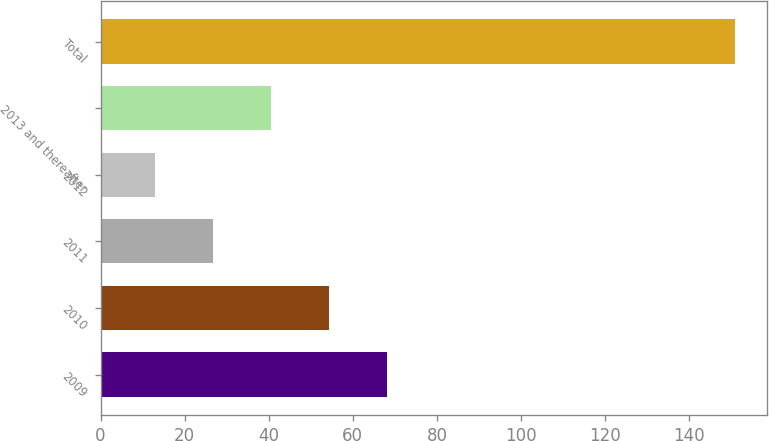Convert chart. <chart><loc_0><loc_0><loc_500><loc_500><bar_chart><fcel>2009<fcel>2010<fcel>2011<fcel>2012<fcel>2013 and thereafter<fcel>Total<nl><fcel>68.2<fcel>54.4<fcel>26.8<fcel>13<fcel>40.6<fcel>151<nl></chart> 